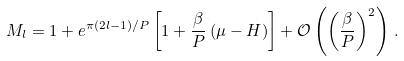<formula> <loc_0><loc_0><loc_500><loc_500>M _ { l } = 1 + e ^ { \pi ( 2 l - 1 ) / P } \left [ 1 + \frac { \beta } { P } \left ( \mu - H \right ) \right ] + \mathcal { O } \left ( \left ( \frac { \beta } { P } \right ) ^ { 2 } \right ) \, .</formula> 